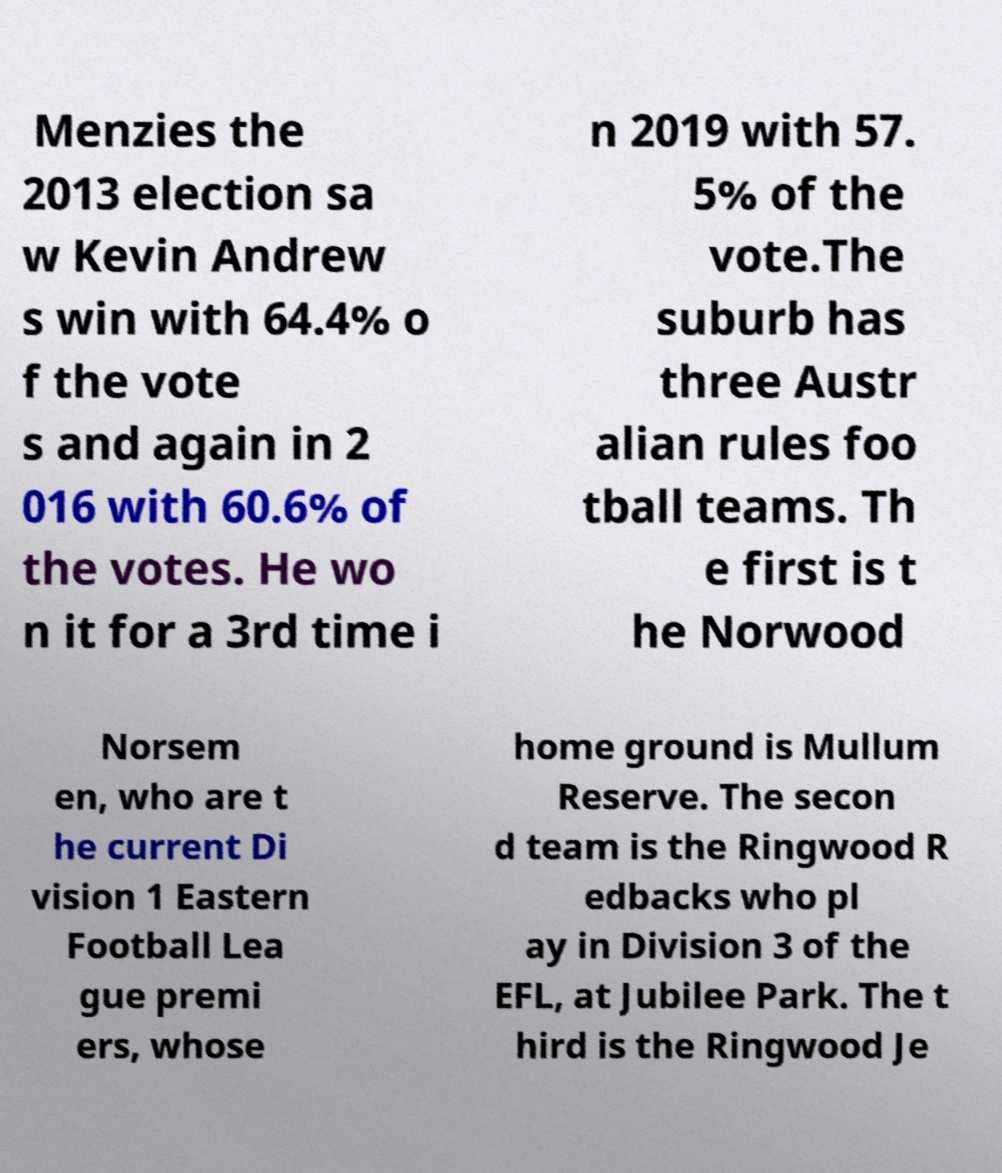Please read and relay the text visible in this image. What does it say? Menzies the 2013 election sa w Kevin Andrew s win with 64.4% o f the vote s and again in 2 016 with 60.6% of the votes. He wo n it for a 3rd time i n 2019 with 57. 5% of the vote.The suburb has three Austr alian rules foo tball teams. Th e first is t he Norwood Norsem en, who are t he current Di vision 1 Eastern Football Lea gue premi ers, whose home ground is Mullum Reserve. The secon d team is the Ringwood R edbacks who pl ay in Division 3 of the EFL, at Jubilee Park. The t hird is the Ringwood Je 